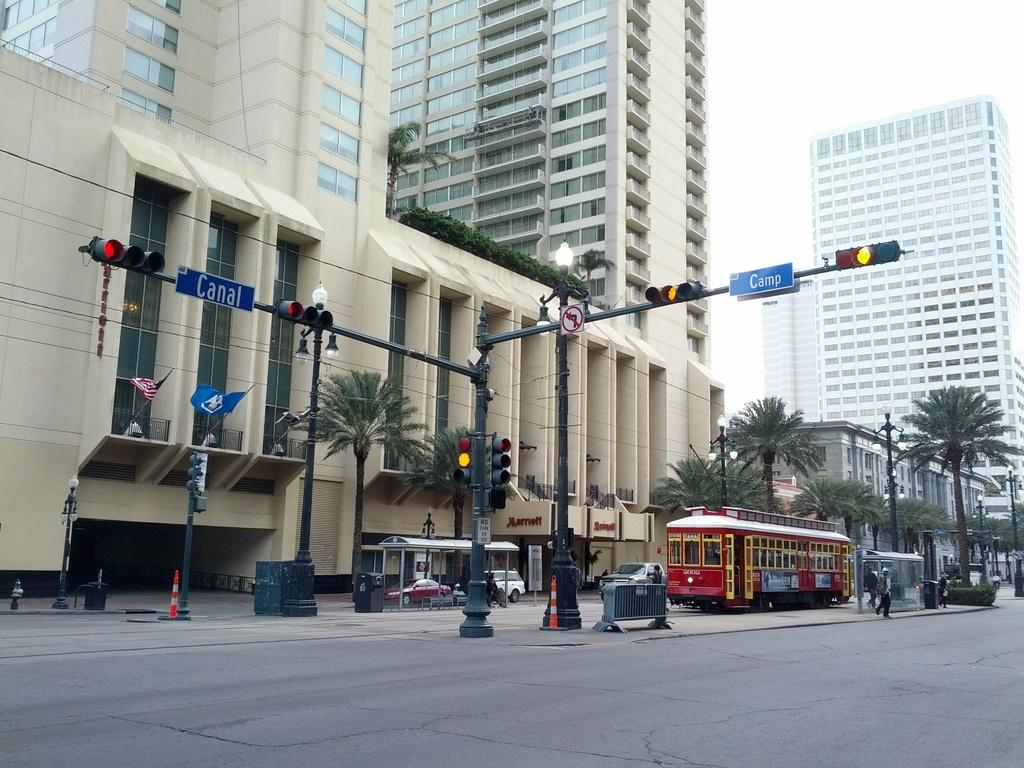<image>
Share a concise interpretation of the image provided. the word camp is on the blue sign next to the light 